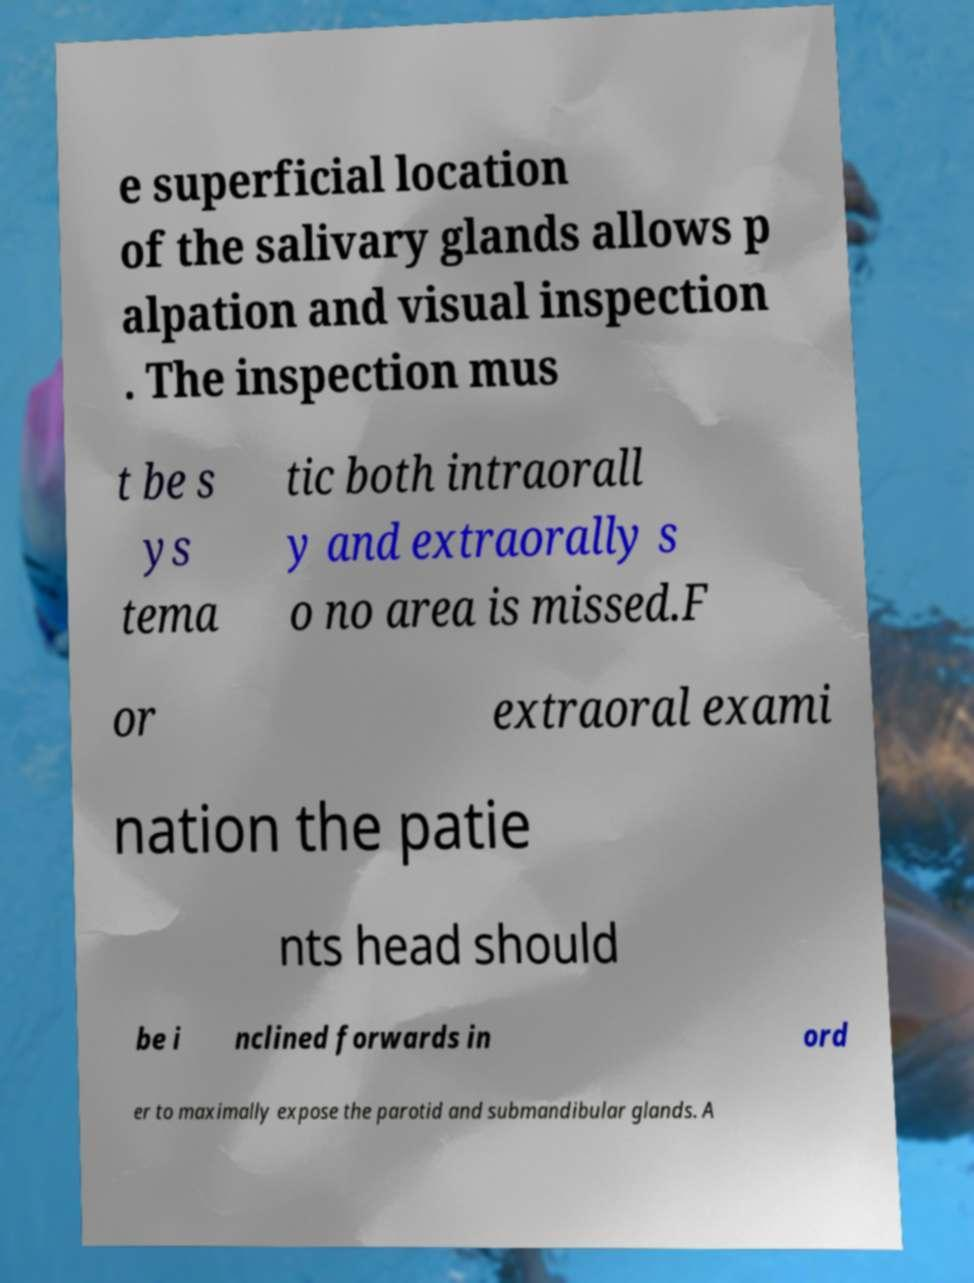Could you assist in decoding the text presented in this image and type it out clearly? e superficial location of the salivary glands allows p alpation and visual inspection . The inspection mus t be s ys tema tic both intraorall y and extraorally s o no area is missed.F or extraoral exami nation the patie nts head should be i nclined forwards in ord er to maximally expose the parotid and submandibular glands. A 